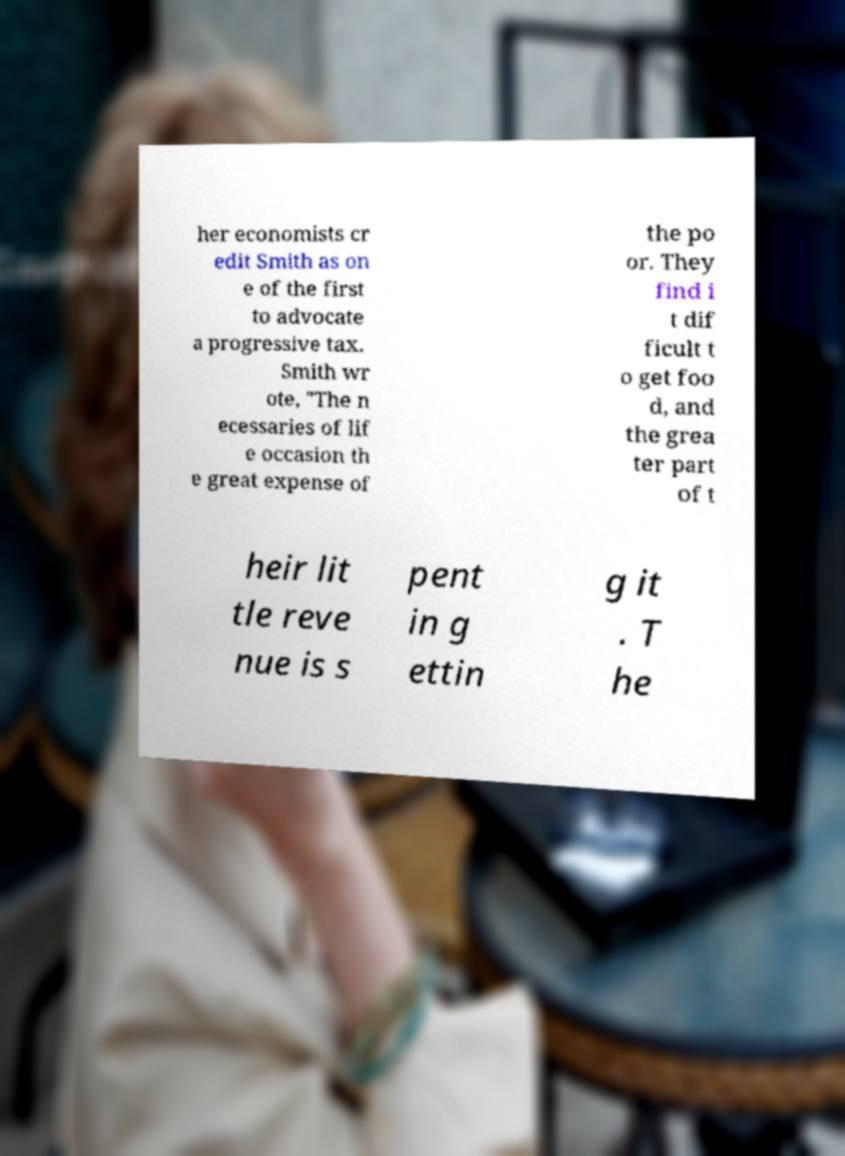For documentation purposes, I need the text within this image transcribed. Could you provide that? her economists cr edit Smith as on e of the first to advocate a progressive tax. Smith wr ote, "The n ecessaries of lif e occasion th e great expense of the po or. They find i t dif ficult t o get foo d, and the grea ter part of t heir lit tle reve nue is s pent in g ettin g it . T he 